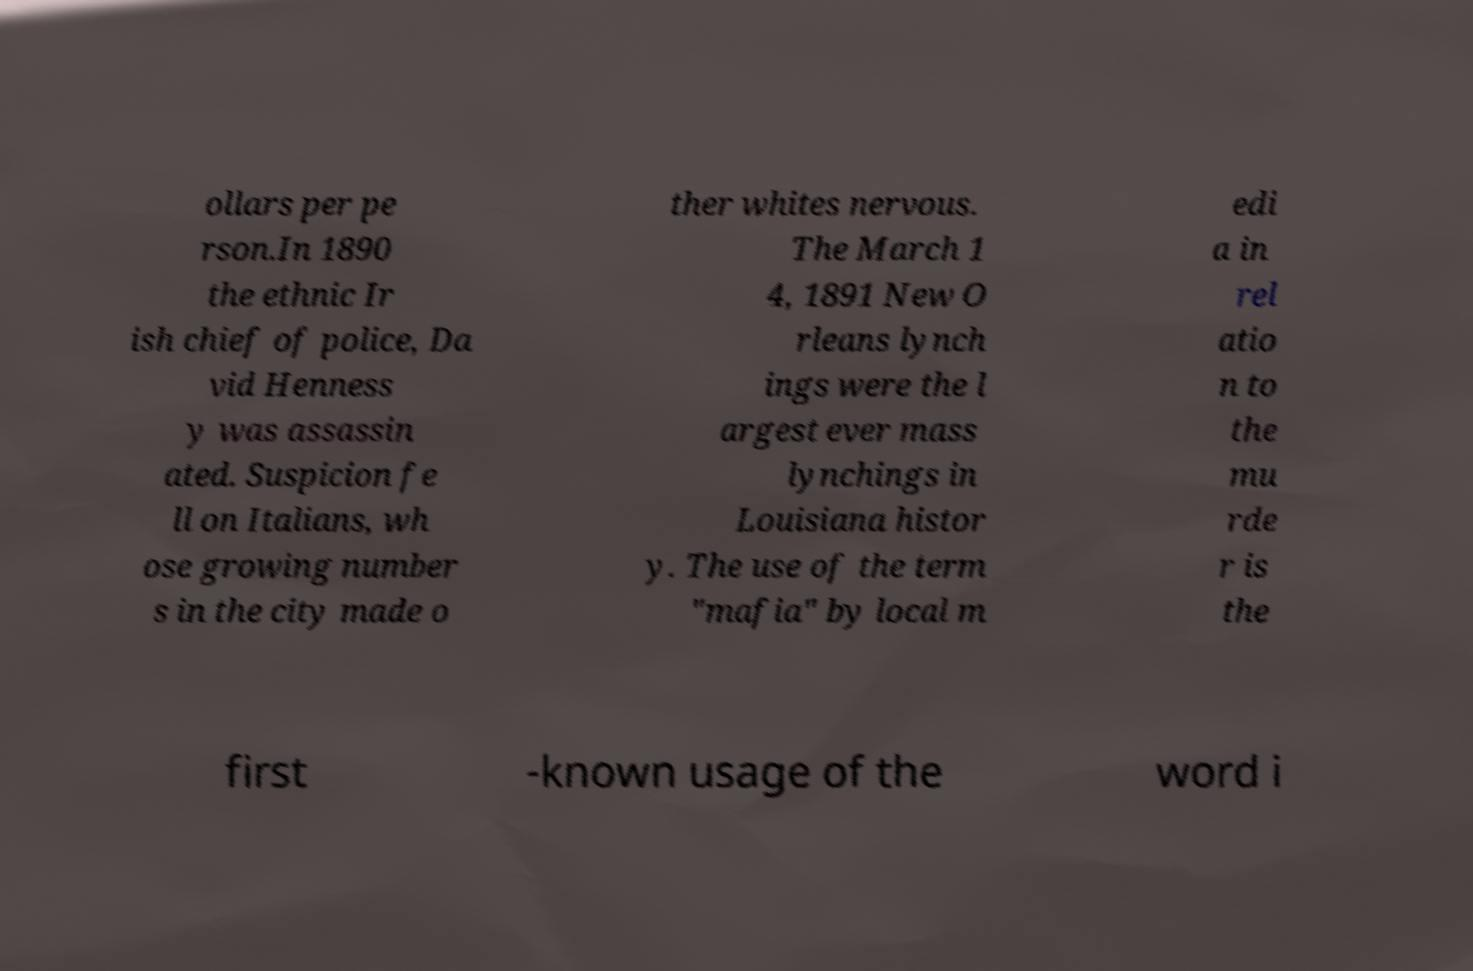Can you read and provide the text displayed in the image?This photo seems to have some interesting text. Can you extract and type it out for me? ollars per pe rson.In 1890 the ethnic Ir ish chief of police, Da vid Henness y was assassin ated. Suspicion fe ll on Italians, wh ose growing number s in the city made o ther whites nervous. The March 1 4, 1891 New O rleans lynch ings were the l argest ever mass lynchings in Louisiana histor y. The use of the term "mafia" by local m edi a in rel atio n to the mu rde r is the first -known usage of the word i 